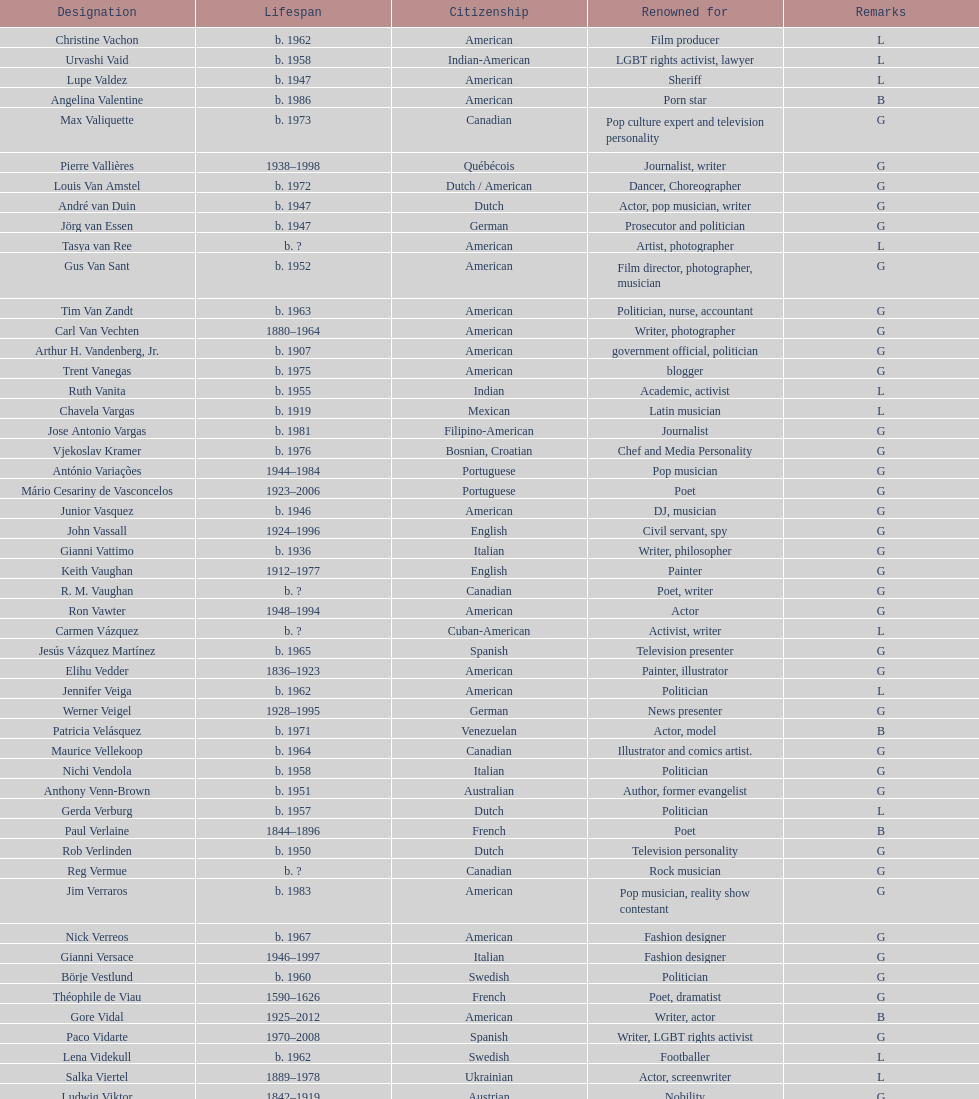Write the full table. {'header': ['Designation', 'Lifespan', 'Citizenship', 'Renowned for', 'Remarks'], 'rows': [['Christine Vachon', 'b. 1962', 'American', 'Film producer', 'L'], ['Urvashi Vaid', 'b. 1958', 'Indian-American', 'LGBT rights activist, lawyer', 'L'], ['Lupe Valdez', 'b. 1947', 'American', 'Sheriff', 'L'], ['Angelina Valentine', 'b. 1986', 'American', 'Porn star', 'B'], ['Max Valiquette', 'b. 1973', 'Canadian', 'Pop culture expert and television personality', 'G'], ['Pierre Vallières', '1938–1998', 'Québécois', 'Journalist, writer', 'G'], ['Louis Van Amstel', 'b. 1972', 'Dutch / American', 'Dancer, Choreographer', 'G'], ['André van Duin', 'b. 1947', 'Dutch', 'Actor, pop musician, writer', 'G'], ['Jörg van Essen', 'b. 1947', 'German', 'Prosecutor and politician', 'G'], ['Tasya van Ree', 'b.\xa0?', 'American', 'Artist, photographer', 'L'], ['Gus Van Sant', 'b. 1952', 'American', 'Film director, photographer, musician', 'G'], ['Tim Van Zandt', 'b. 1963', 'American', 'Politician, nurse, accountant', 'G'], ['Carl Van Vechten', '1880–1964', 'American', 'Writer, photographer', 'G'], ['Arthur H. Vandenberg, Jr.', 'b. 1907', 'American', 'government official, politician', 'G'], ['Trent Vanegas', 'b. 1975', 'American', 'blogger', 'G'], ['Ruth Vanita', 'b. 1955', 'Indian', 'Academic, activist', 'L'], ['Chavela Vargas', 'b. 1919', 'Mexican', 'Latin musician', 'L'], ['Jose Antonio Vargas', 'b. 1981', 'Filipino-American', 'Journalist', 'G'], ['Vjekoslav Kramer', 'b. 1976', 'Bosnian, Croatian', 'Chef and Media Personality', 'G'], ['António Variações', '1944–1984', 'Portuguese', 'Pop musician', 'G'], ['Mário Cesariny de Vasconcelos', '1923–2006', 'Portuguese', 'Poet', 'G'], ['Junior Vasquez', 'b. 1946', 'American', 'DJ, musician', 'G'], ['John Vassall', '1924–1996', 'English', 'Civil servant, spy', 'G'], ['Gianni Vattimo', 'b. 1936', 'Italian', 'Writer, philosopher', 'G'], ['Keith Vaughan', '1912–1977', 'English', 'Painter', 'G'], ['R. M. Vaughan', 'b.\xa0?', 'Canadian', 'Poet, writer', 'G'], ['Ron Vawter', '1948–1994', 'American', 'Actor', 'G'], ['Carmen Vázquez', 'b.\xa0?', 'Cuban-American', 'Activist, writer', 'L'], ['Jesús Vázquez Martínez', 'b. 1965', 'Spanish', 'Television presenter', 'G'], ['Elihu Vedder', '1836–1923', 'American', 'Painter, illustrator', 'G'], ['Jennifer Veiga', 'b. 1962', 'American', 'Politician', 'L'], ['Werner Veigel', '1928–1995', 'German', 'News presenter', 'G'], ['Patricia Velásquez', 'b. 1971', 'Venezuelan', 'Actor, model', 'B'], ['Maurice Vellekoop', 'b. 1964', 'Canadian', 'Illustrator and comics artist.', 'G'], ['Nichi Vendola', 'b. 1958', 'Italian', 'Politician', 'G'], ['Anthony Venn-Brown', 'b. 1951', 'Australian', 'Author, former evangelist', 'G'], ['Gerda Verburg', 'b. 1957', 'Dutch', 'Politician', 'L'], ['Paul Verlaine', '1844–1896', 'French', 'Poet', 'B'], ['Rob Verlinden', 'b. 1950', 'Dutch', 'Television personality', 'G'], ['Reg Vermue', 'b.\xa0?', 'Canadian', 'Rock musician', 'G'], ['Jim Verraros', 'b. 1983', 'American', 'Pop musician, reality show contestant', 'G'], ['Nick Verreos', 'b. 1967', 'American', 'Fashion designer', 'G'], ['Gianni Versace', '1946–1997', 'Italian', 'Fashion designer', 'G'], ['Börje Vestlund', 'b. 1960', 'Swedish', 'Politician', 'G'], ['Théophile de Viau', '1590–1626', 'French', 'Poet, dramatist', 'G'], ['Gore Vidal', '1925–2012', 'American', 'Writer, actor', 'B'], ['Paco Vidarte', '1970–2008', 'Spanish', 'Writer, LGBT rights activist', 'G'], ['Lena Videkull', 'b. 1962', 'Swedish', 'Footballer', 'L'], ['Salka Viertel', '1889–1978', 'Ukrainian', 'Actor, screenwriter', 'L'], ['Ludwig Viktor', '1842–1919', 'Austrian', 'Nobility', 'G'], ['Bruce Vilanch', 'b. 1948', 'American', 'Comedy writer, actor', 'G'], ['Tom Villard', '1953–1994', 'American', 'Actor', 'G'], ['José Villarrubia', 'b. 1961', 'American', 'Artist', 'G'], ['Xavier Villaurrutia', '1903–1950', 'Mexican', 'Poet, playwright', 'G'], ["Alain-Philippe Malagnac d'Argens de Villèle", '1950–2000', 'French', 'Aristocrat', 'G'], ['Norah Vincent', 'b.\xa0?', 'American', 'Journalist', 'L'], ['Donald Vining', '1917–1998', 'American', 'Writer', 'G'], ['Luchino Visconti', '1906–1976', 'Italian', 'Filmmaker', 'G'], ['Pavel Vítek', 'b. 1962', 'Czech', 'Pop musician, actor', 'G'], ['Renée Vivien', '1877–1909', 'English', 'Poet', 'L'], ['Claude Vivier', '1948–1983', 'Canadian', '20th century classical composer', 'G'], ['Taylor Vixen', 'b. 1983', 'American', 'Porn star', 'B'], ['Bruce Voeller', '1934–1994', 'American', 'HIV/AIDS researcher', 'G'], ['Paula Vogel', 'b. 1951', 'American', 'Playwright', 'L'], ['Julia Volkova', 'b. 1985', 'Russian', 'Singer', 'B'], ['Jörg van Essen', 'b. 1947', 'German', 'Politician', 'G'], ['Ole von Beust', 'b. 1955', 'German', 'Politician', 'G'], ['Wilhelm von Gloeden', '1856–1931', 'German', 'Photographer', 'G'], ['Rosa von Praunheim', 'b. 1942', 'German', 'Film director', 'G'], ['Kurt von Ruffin', 'b. 1901–1996', 'German', 'Holocaust survivor', 'G'], ['Hella von Sinnen', 'b. 1959', 'German', 'Comedian', 'L'], ['Daniel Vosovic', 'b. 1981', 'American', 'Fashion designer', 'G'], ['Delwin Vriend', 'b. 1966', 'Canadian', 'LGBT rights activist', 'G']]} What is the difference in year of borth between vachon and vaid? 4 years. 